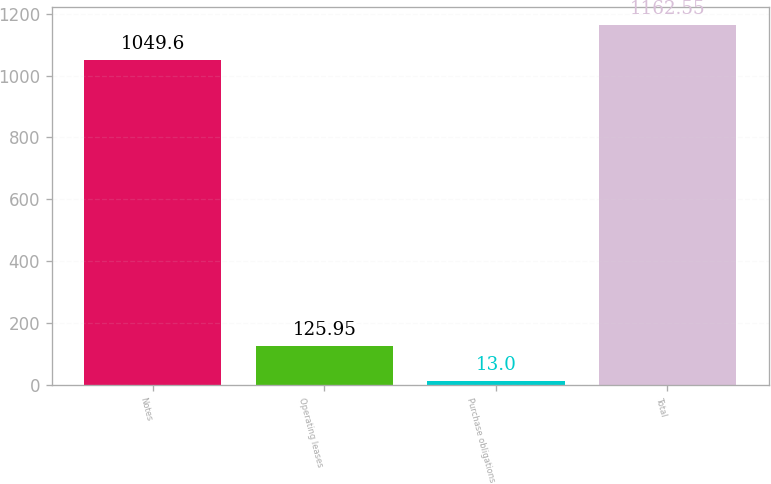Convert chart to OTSL. <chart><loc_0><loc_0><loc_500><loc_500><bar_chart><fcel>Notes<fcel>Operating leases<fcel>Purchase obligations<fcel>Total<nl><fcel>1049.6<fcel>125.95<fcel>13<fcel>1162.55<nl></chart> 